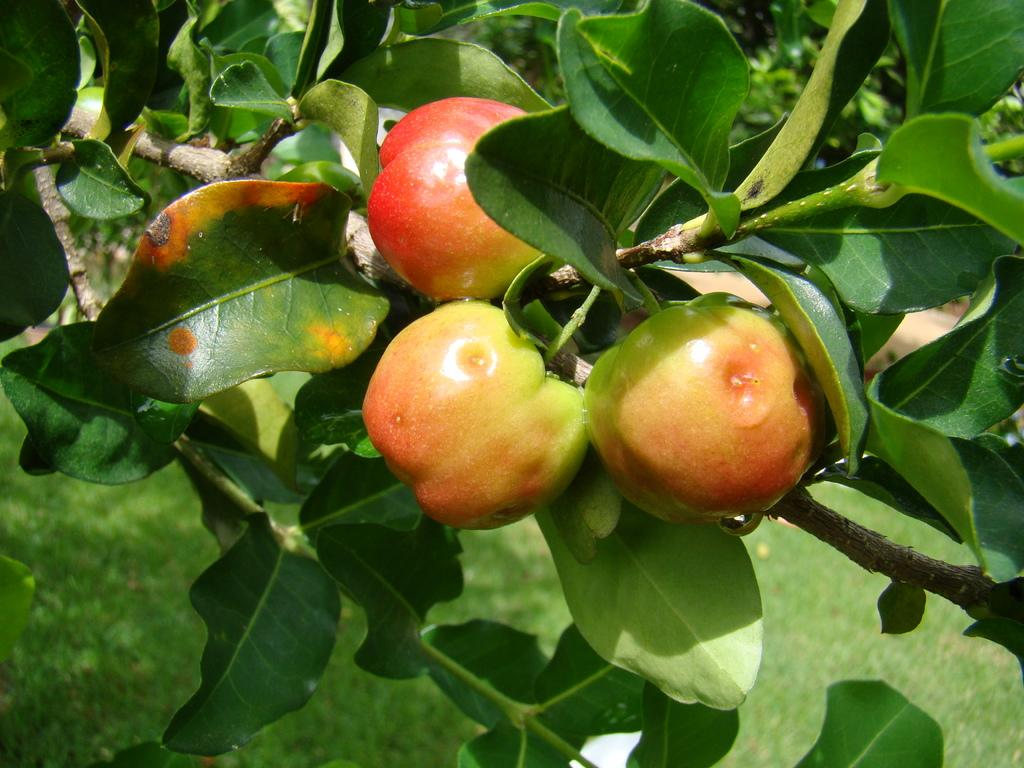What type of plant can be seen in the image? There is a tree in the image. What is the tree's current state? The tree has fruits. What type of vegetation is present on the ground in the image? There is grass on the ground in the image. What type of toys are scattered on the grass in the image? There are no toys present in the image; it only features a tree with fruits and grass on the ground. 